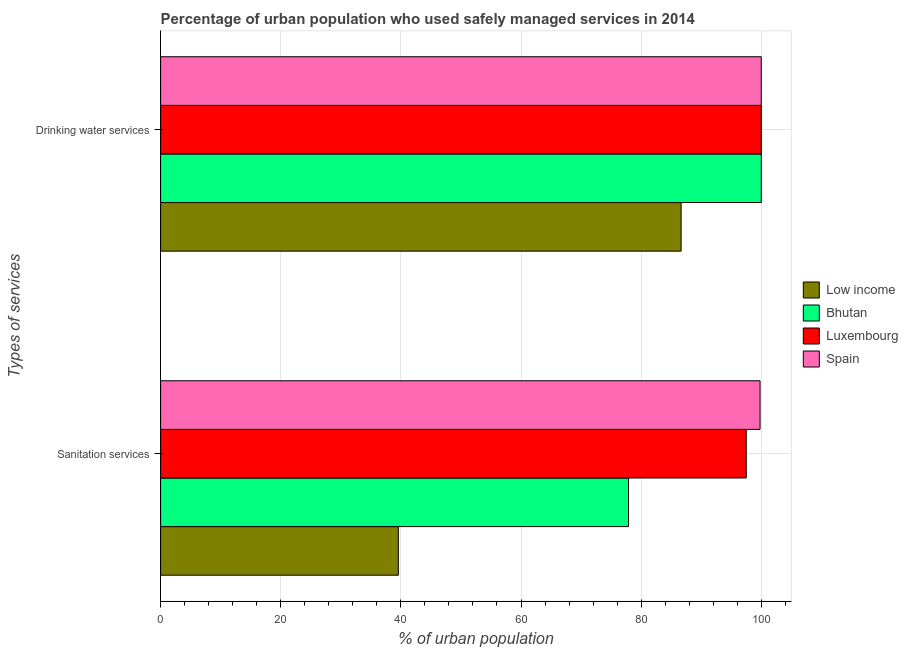How many different coloured bars are there?
Make the answer very short. 4. Are the number of bars per tick equal to the number of legend labels?
Your answer should be very brief. Yes. What is the label of the 2nd group of bars from the top?
Offer a terse response. Sanitation services. What is the percentage of urban population who used sanitation services in Low income?
Provide a succinct answer. 39.58. Across all countries, what is the maximum percentage of urban population who used sanitation services?
Your answer should be very brief. 99.8. Across all countries, what is the minimum percentage of urban population who used sanitation services?
Keep it short and to the point. 39.58. In which country was the percentage of urban population who used drinking water services maximum?
Provide a short and direct response. Bhutan. In which country was the percentage of urban population who used drinking water services minimum?
Offer a terse response. Low income. What is the total percentage of urban population who used drinking water services in the graph?
Keep it short and to the point. 386.66. What is the difference between the percentage of urban population who used sanitation services in Spain and that in Luxembourg?
Offer a very short reply. 2.3. What is the difference between the percentage of urban population who used sanitation services in Low income and the percentage of urban population who used drinking water services in Luxembourg?
Make the answer very short. -60.42. What is the average percentage of urban population who used sanitation services per country?
Your answer should be very brief. 78.7. What is the difference between the percentage of urban population who used drinking water services and percentage of urban population who used sanitation services in Bhutan?
Offer a terse response. 22.1. In how many countries, is the percentage of urban population who used drinking water services greater than 60 %?
Offer a very short reply. 4. What is the ratio of the percentage of urban population who used drinking water services in Spain to that in Low income?
Ensure brevity in your answer.  1.15. In how many countries, is the percentage of urban population who used sanitation services greater than the average percentage of urban population who used sanitation services taken over all countries?
Ensure brevity in your answer.  2. What does the 3rd bar from the top in Drinking water services represents?
Offer a terse response. Bhutan. What does the 2nd bar from the bottom in Drinking water services represents?
Ensure brevity in your answer.  Bhutan. How many countries are there in the graph?
Provide a short and direct response. 4. What is the difference between two consecutive major ticks on the X-axis?
Ensure brevity in your answer.  20. Does the graph contain any zero values?
Make the answer very short. No. How are the legend labels stacked?
Provide a short and direct response. Vertical. What is the title of the graph?
Ensure brevity in your answer.  Percentage of urban population who used safely managed services in 2014. Does "High income: nonOECD" appear as one of the legend labels in the graph?
Your answer should be compact. No. What is the label or title of the X-axis?
Make the answer very short. % of urban population. What is the label or title of the Y-axis?
Offer a very short reply. Types of services. What is the % of urban population in Low income in Sanitation services?
Provide a short and direct response. 39.58. What is the % of urban population in Bhutan in Sanitation services?
Give a very brief answer. 77.9. What is the % of urban population of Luxembourg in Sanitation services?
Keep it short and to the point. 97.5. What is the % of urban population of Spain in Sanitation services?
Keep it short and to the point. 99.8. What is the % of urban population of Low income in Drinking water services?
Provide a succinct answer. 86.66. What is the % of urban population of Bhutan in Drinking water services?
Offer a very short reply. 100. What is the % of urban population in Luxembourg in Drinking water services?
Keep it short and to the point. 100. What is the % of urban population of Spain in Drinking water services?
Offer a very short reply. 100. Across all Types of services, what is the maximum % of urban population of Low income?
Make the answer very short. 86.66. Across all Types of services, what is the maximum % of urban population of Bhutan?
Ensure brevity in your answer.  100. Across all Types of services, what is the maximum % of urban population of Luxembourg?
Your response must be concise. 100. Across all Types of services, what is the minimum % of urban population in Low income?
Provide a short and direct response. 39.58. Across all Types of services, what is the minimum % of urban population of Bhutan?
Your response must be concise. 77.9. Across all Types of services, what is the minimum % of urban population in Luxembourg?
Offer a very short reply. 97.5. Across all Types of services, what is the minimum % of urban population in Spain?
Provide a succinct answer. 99.8. What is the total % of urban population in Low income in the graph?
Keep it short and to the point. 126.24. What is the total % of urban population of Bhutan in the graph?
Your answer should be compact. 177.9. What is the total % of urban population in Luxembourg in the graph?
Ensure brevity in your answer.  197.5. What is the total % of urban population in Spain in the graph?
Keep it short and to the point. 199.8. What is the difference between the % of urban population of Low income in Sanitation services and that in Drinking water services?
Ensure brevity in your answer.  -47.08. What is the difference between the % of urban population of Bhutan in Sanitation services and that in Drinking water services?
Your answer should be compact. -22.1. What is the difference between the % of urban population in Luxembourg in Sanitation services and that in Drinking water services?
Your answer should be very brief. -2.5. What is the difference between the % of urban population in Low income in Sanitation services and the % of urban population in Bhutan in Drinking water services?
Give a very brief answer. -60.42. What is the difference between the % of urban population in Low income in Sanitation services and the % of urban population in Luxembourg in Drinking water services?
Provide a succinct answer. -60.42. What is the difference between the % of urban population of Low income in Sanitation services and the % of urban population of Spain in Drinking water services?
Keep it short and to the point. -60.42. What is the difference between the % of urban population of Bhutan in Sanitation services and the % of urban population of Luxembourg in Drinking water services?
Provide a succinct answer. -22.1. What is the difference between the % of urban population in Bhutan in Sanitation services and the % of urban population in Spain in Drinking water services?
Ensure brevity in your answer.  -22.1. What is the difference between the % of urban population of Luxembourg in Sanitation services and the % of urban population of Spain in Drinking water services?
Offer a very short reply. -2.5. What is the average % of urban population in Low income per Types of services?
Keep it short and to the point. 63.12. What is the average % of urban population in Bhutan per Types of services?
Keep it short and to the point. 88.95. What is the average % of urban population of Luxembourg per Types of services?
Offer a very short reply. 98.75. What is the average % of urban population of Spain per Types of services?
Give a very brief answer. 99.9. What is the difference between the % of urban population of Low income and % of urban population of Bhutan in Sanitation services?
Provide a short and direct response. -38.32. What is the difference between the % of urban population in Low income and % of urban population in Luxembourg in Sanitation services?
Provide a short and direct response. -57.92. What is the difference between the % of urban population in Low income and % of urban population in Spain in Sanitation services?
Make the answer very short. -60.22. What is the difference between the % of urban population of Bhutan and % of urban population of Luxembourg in Sanitation services?
Offer a very short reply. -19.6. What is the difference between the % of urban population of Bhutan and % of urban population of Spain in Sanitation services?
Provide a short and direct response. -21.9. What is the difference between the % of urban population in Low income and % of urban population in Bhutan in Drinking water services?
Make the answer very short. -13.34. What is the difference between the % of urban population of Low income and % of urban population of Luxembourg in Drinking water services?
Give a very brief answer. -13.34. What is the difference between the % of urban population of Low income and % of urban population of Spain in Drinking water services?
Your response must be concise. -13.34. What is the difference between the % of urban population in Bhutan and % of urban population in Luxembourg in Drinking water services?
Give a very brief answer. 0. What is the difference between the % of urban population in Bhutan and % of urban population in Spain in Drinking water services?
Your response must be concise. 0. What is the difference between the % of urban population in Luxembourg and % of urban population in Spain in Drinking water services?
Keep it short and to the point. 0. What is the ratio of the % of urban population of Low income in Sanitation services to that in Drinking water services?
Keep it short and to the point. 0.46. What is the ratio of the % of urban population of Bhutan in Sanitation services to that in Drinking water services?
Your answer should be very brief. 0.78. What is the ratio of the % of urban population in Luxembourg in Sanitation services to that in Drinking water services?
Offer a terse response. 0.97. What is the difference between the highest and the second highest % of urban population in Low income?
Your answer should be compact. 47.08. What is the difference between the highest and the second highest % of urban population in Bhutan?
Your response must be concise. 22.1. What is the difference between the highest and the second highest % of urban population of Luxembourg?
Ensure brevity in your answer.  2.5. What is the difference between the highest and the lowest % of urban population in Low income?
Offer a very short reply. 47.08. What is the difference between the highest and the lowest % of urban population of Bhutan?
Offer a terse response. 22.1. 